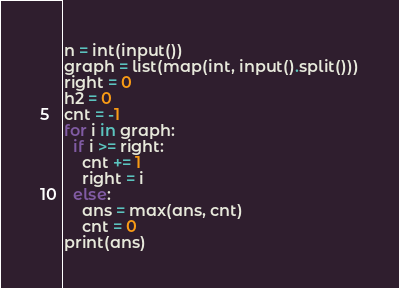<code> <loc_0><loc_0><loc_500><loc_500><_Python_>n = int(input())
graph = list(map(int, input().split()))
right = 0
h2 = 0
cnt = -1
for i in graph:
  if i >= right:
    cnt += 1
    right = i
  else:
    ans = max(ans, cnt)
    cnt = 0
print(ans)</code> 